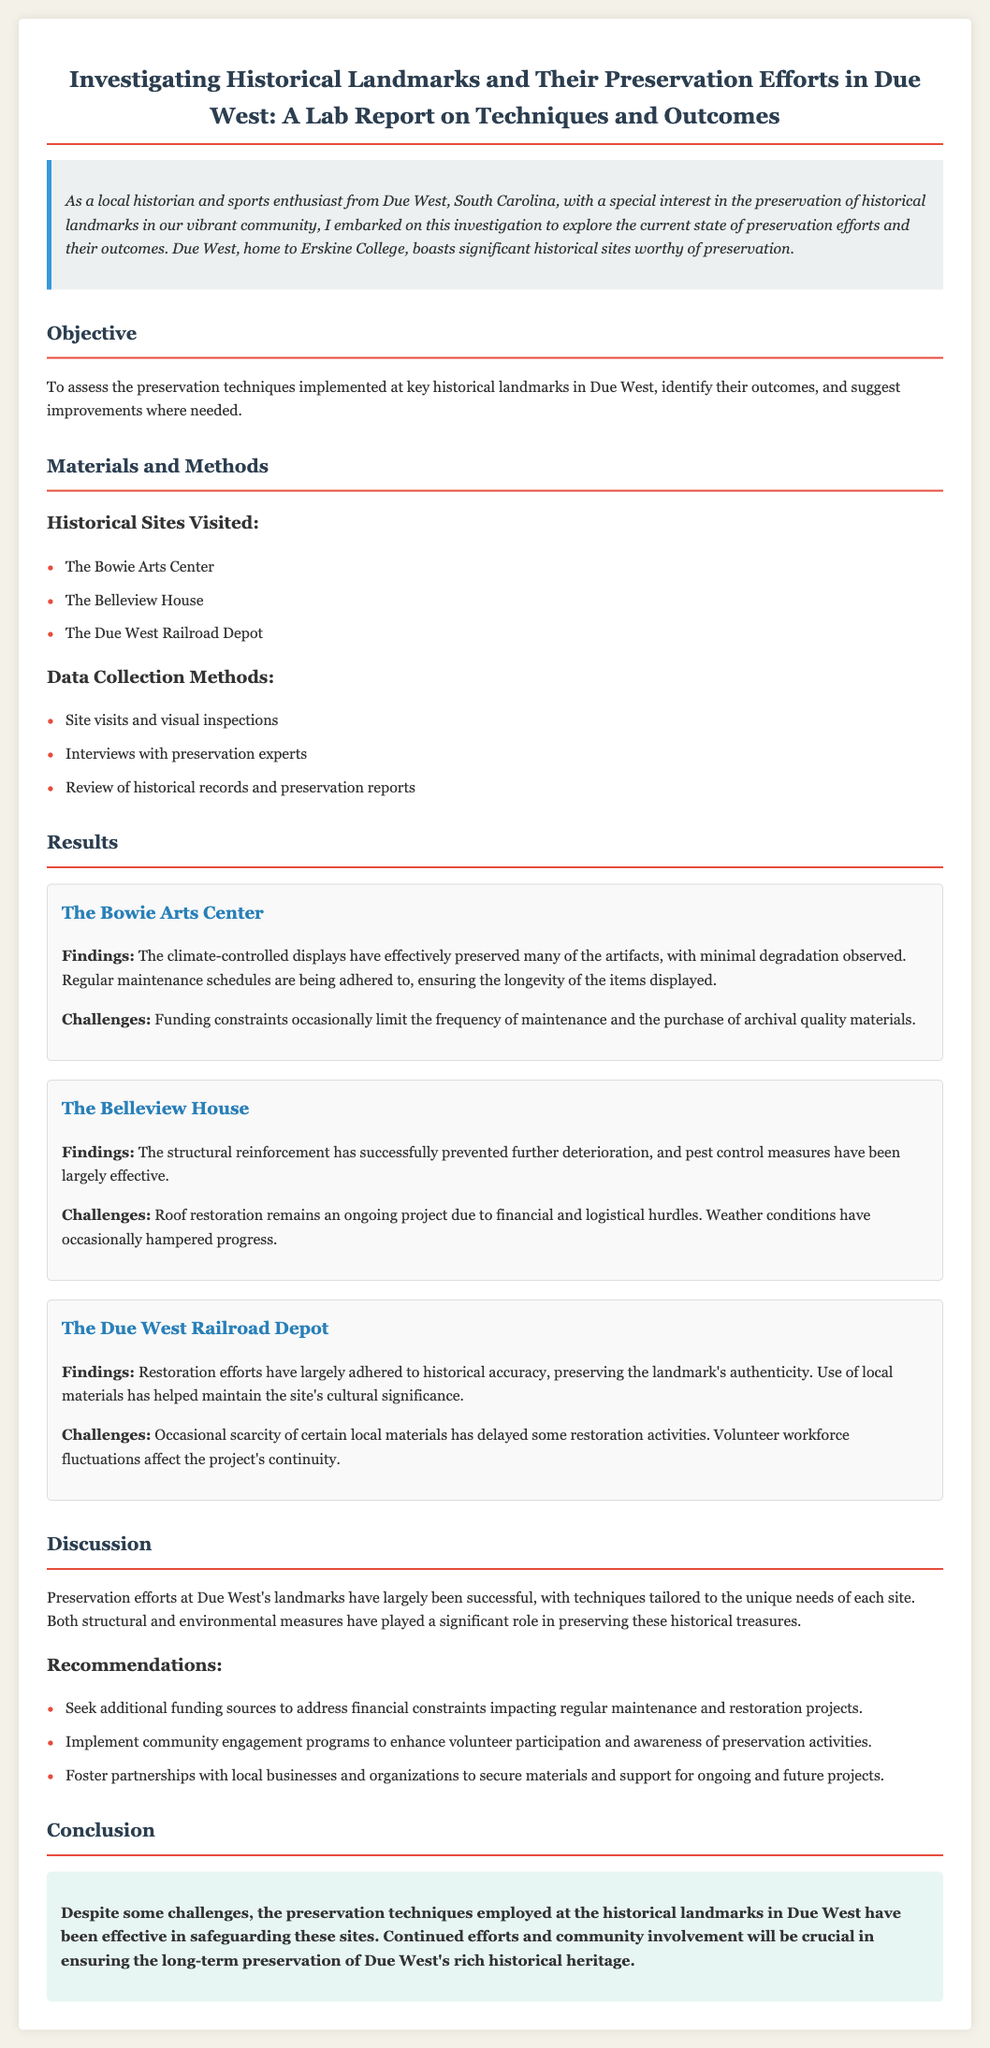what is the main objective of the report? The main objective is to assess the preservation techniques implemented at key historical landmarks in Due West, identify their outcomes, and suggest improvements where needed.
Answer: to assess the preservation techniques how many historical sites were visited in the study? The report lists three historical sites visited during the investigation.
Answer: three what are the two challenges faced at The Bowie Arts Center? The report mentions funding constraints limiting maintenance and materials.
Answer: funding constraints who was primarily involved in the data collection methods? The data collection included interviews with preservation experts and visual inspections.
Answer: preservation experts what preservation method is highlighted in The Belleview House? The report notes that structural reinforcement has been successfully implemented.
Answer: structural reinforcement what is one recommendation given in the report? The report suggests seeking additional funding sources to address financial constraints.
Answer: seek additional funding sources how has the Due West Railroad Depot preserved its authenticity? The report states that restoration efforts largely adhered to historical accuracy.
Answer: historical accuracy what is the environmental condition mentioned in the introduction? The introduction highlights the vibrant community of Due West.
Answer: vibrant community what was the purpose of site visits in this study? Site visits were conducted to perform visual inspections of the landmarks.
Answer: visual inspections 